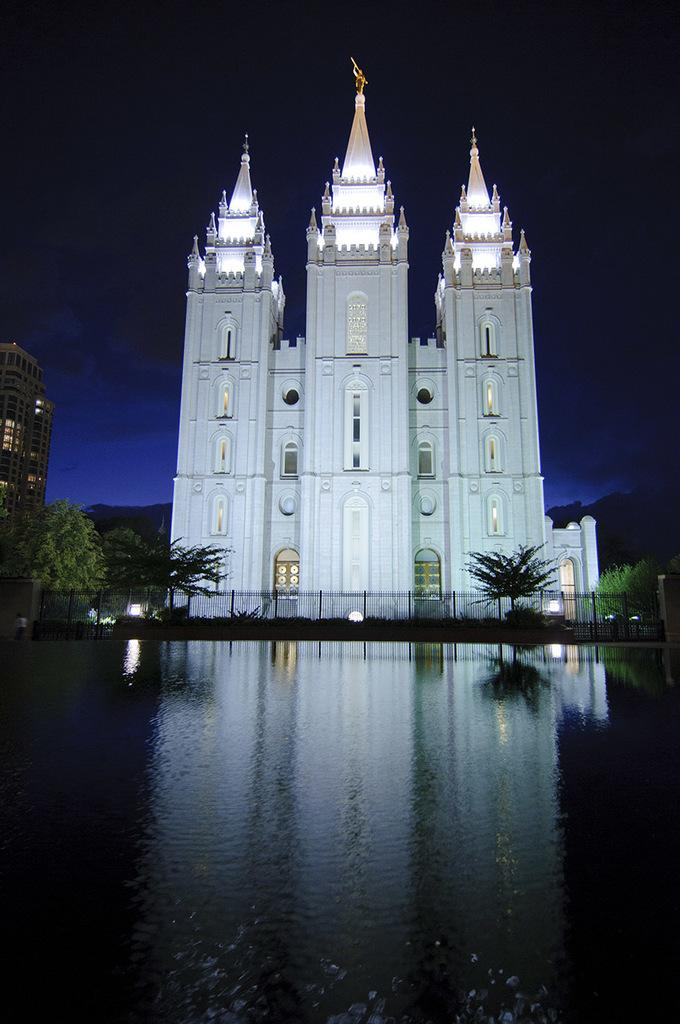What is the main feature in the center of the image? There is a water body in the center of the image. What can be seen in the background of the image? There are buildings, trees, lights, and a fence in the background of the image. What type of bead is hanging from the roof in the image? There is no bead or roof present in the image. What season is depicted in the image, considering the presence of winter clothing? There is no indication of winter clothing or any specific season in the image. 